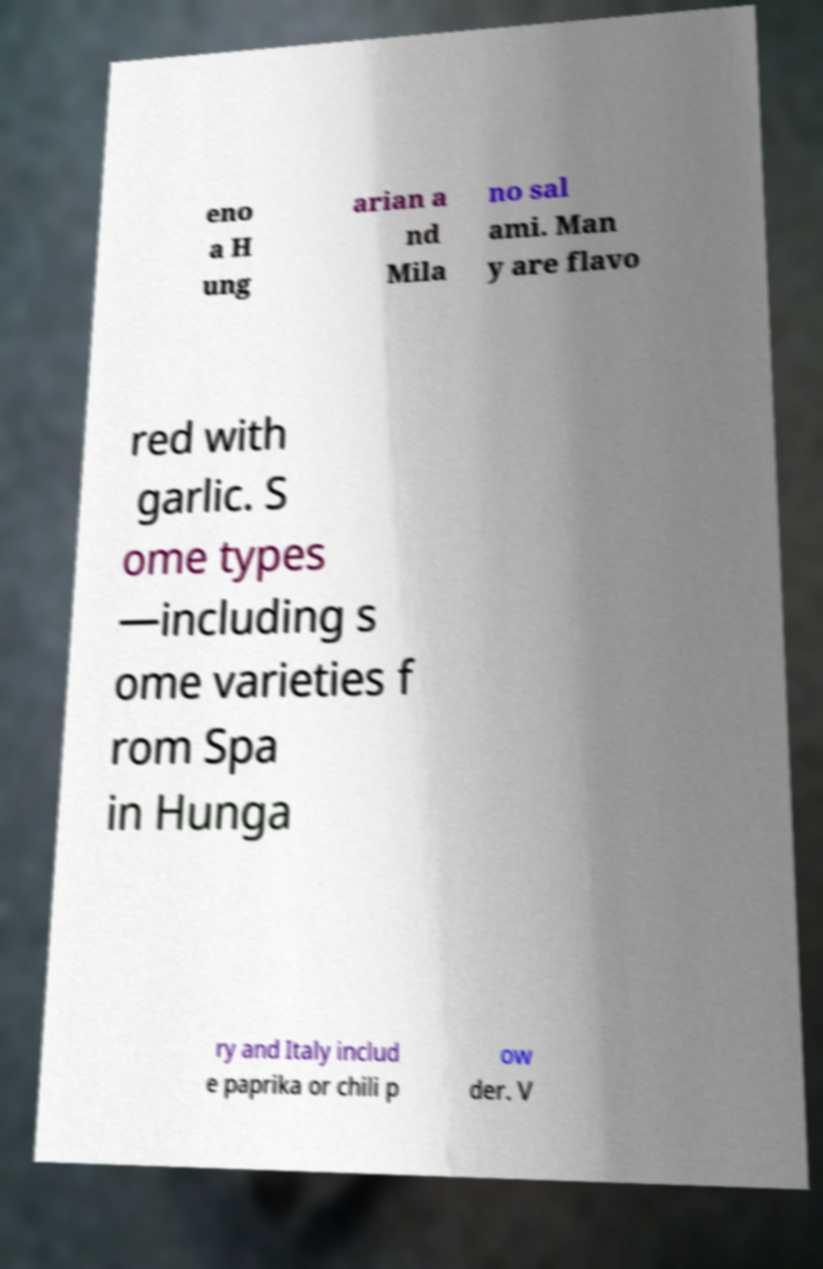Please read and relay the text visible in this image. What does it say? eno a H ung arian a nd Mila no sal ami. Man y are flavo red with garlic. S ome types —including s ome varieties f rom Spa in Hunga ry and Italy includ e paprika or chili p ow der. V 